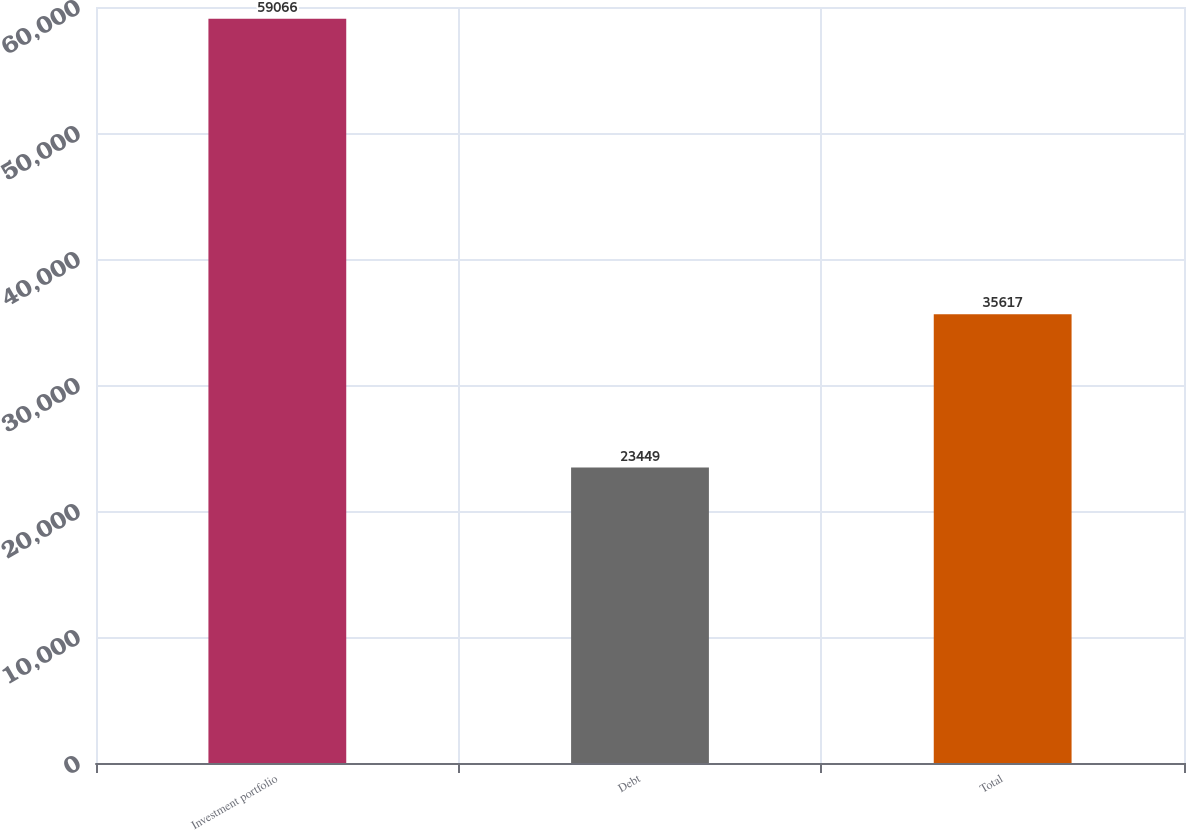Convert chart to OTSL. <chart><loc_0><loc_0><loc_500><loc_500><bar_chart><fcel>Investment portfolio<fcel>Debt<fcel>Total<nl><fcel>59066<fcel>23449<fcel>35617<nl></chart> 